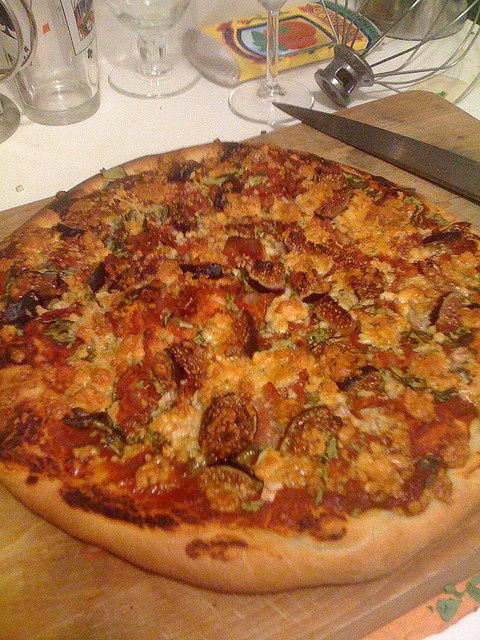Describe the objects in this image and their specific colors. I can see pizza in darkgreen, brown, maroon, and tan tones, wine glass in darkgreen, tan, darkgray, and lightgray tones, knife in darkgreen, olive, maroon, brown, and purple tones, and wine glass in darkgreen, tan, lightgray, and darkgray tones in this image. 